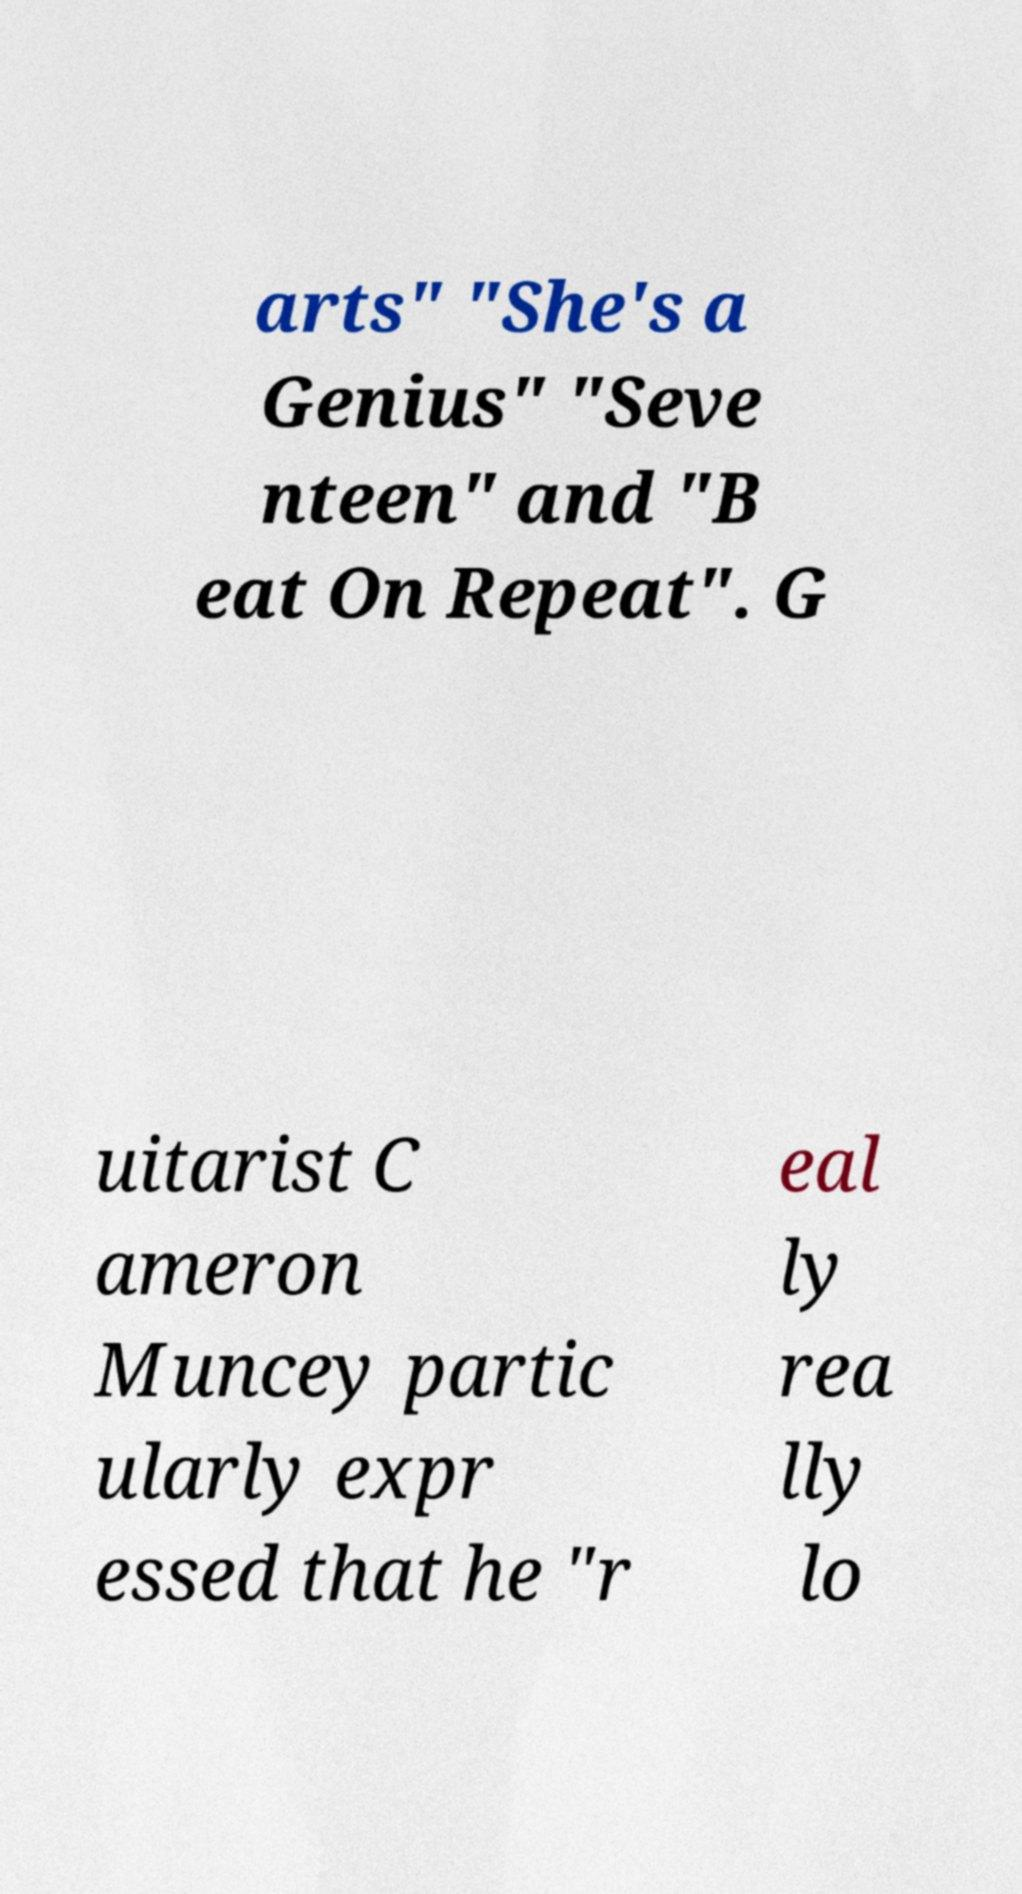What messages or text are displayed in this image? I need them in a readable, typed format. arts" "She's a Genius" "Seve nteen" and "B eat On Repeat". G uitarist C ameron Muncey partic ularly expr essed that he "r eal ly rea lly lo 